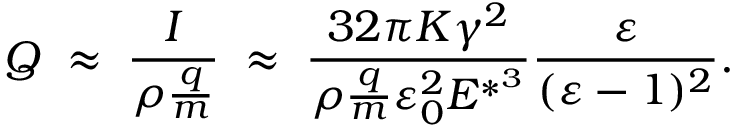<formula> <loc_0><loc_0><loc_500><loc_500>Q \, \approx \, \frac { I } { \rho \frac { q } { m } } \, \approx \, \frac { 3 2 \pi K \gamma ^ { 2 } } { \rho \frac { q } { m } \varepsilon _ { 0 } ^ { 2 } E ^ { * ^ { 3 } } } \frac { \varepsilon } { ( \varepsilon - 1 ) ^ { 2 } } .</formula> 